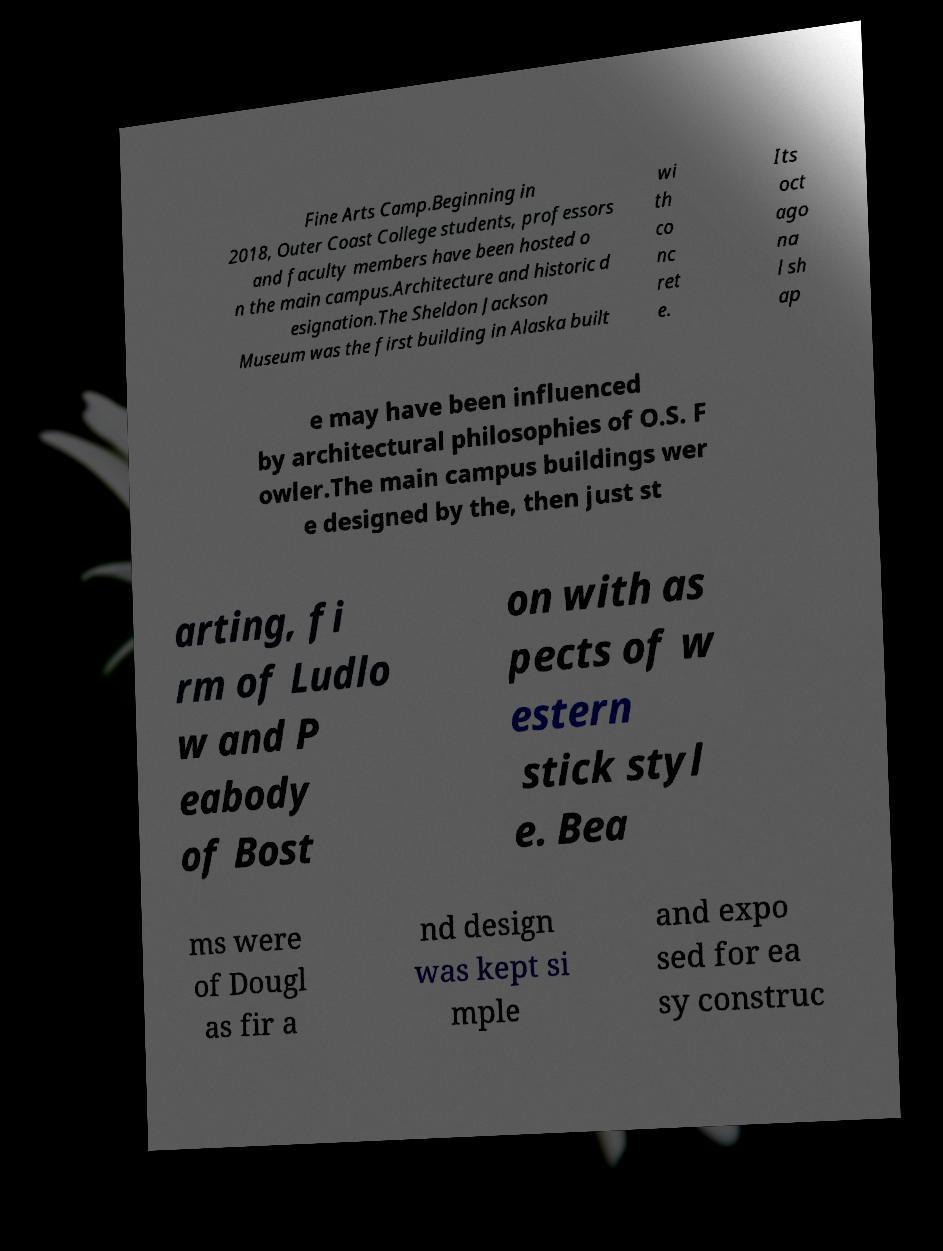I need the written content from this picture converted into text. Can you do that? Fine Arts Camp.Beginning in 2018, Outer Coast College students, professors and faculty members have been hosted o n the main campus.Architecture and historic d esignation.The Sheldon Jackson Museum was the first building in Alaska built wi th co nc ret e. Its oct ago na l sh ap e may have been influenced by architectural philosophies of O.S. F owler.The main campus buildings wer e designed by the, then just st arting, fi rm of Ludlo w and P eabody of Bost on with as pects of w estern stick styl e. Bea ms were of Dougl as fir a nd design was kept si mple and expo sed for ea sy construc 